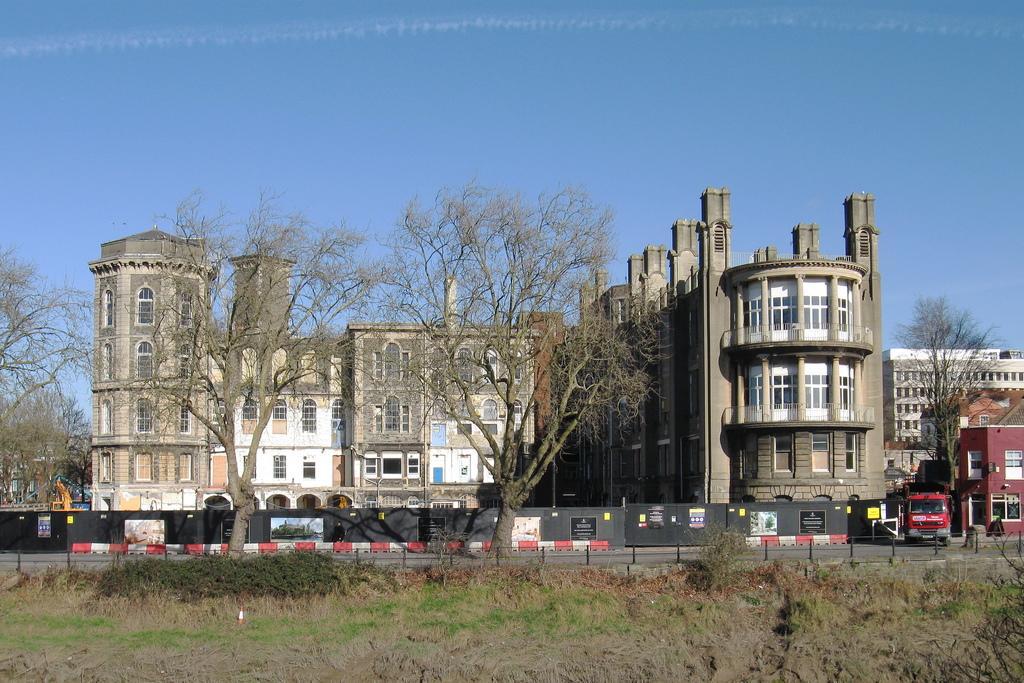In one or two sentences, can you explain what this image depicts? In this picture there is a old castle type building with many windows. In the front we can see two dry trees. In the front bottom side we can see fencing railing and a ground. 